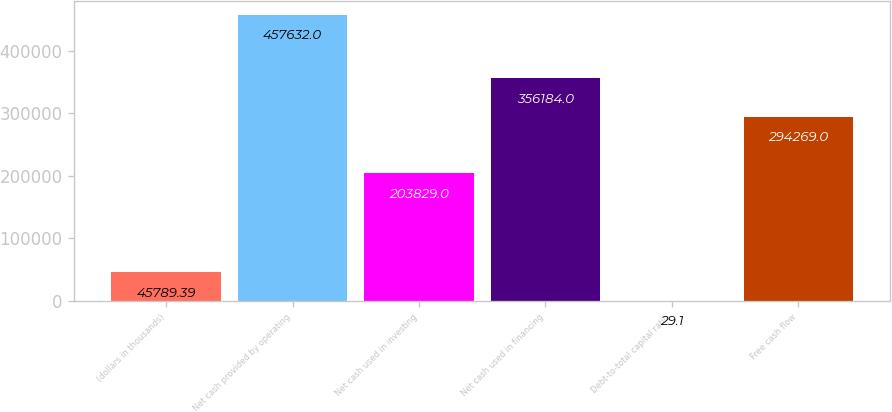Convert chart. <chart><loc_0><loc_0><loc_500><loc_500><bar_chart><fcel>(dollars in thousands)<fcel>Net cash provided by operating<fcel>Net cash used in investing<fcel>Net cash used in financing<fcel>Debt-to-total capital ratio<fcel>Free cash flow<nl><fcel>45789.4<fcel>457632<fcel>203829<fcel>356184<fcel>29.1<fcel>294269<nl></chart> 